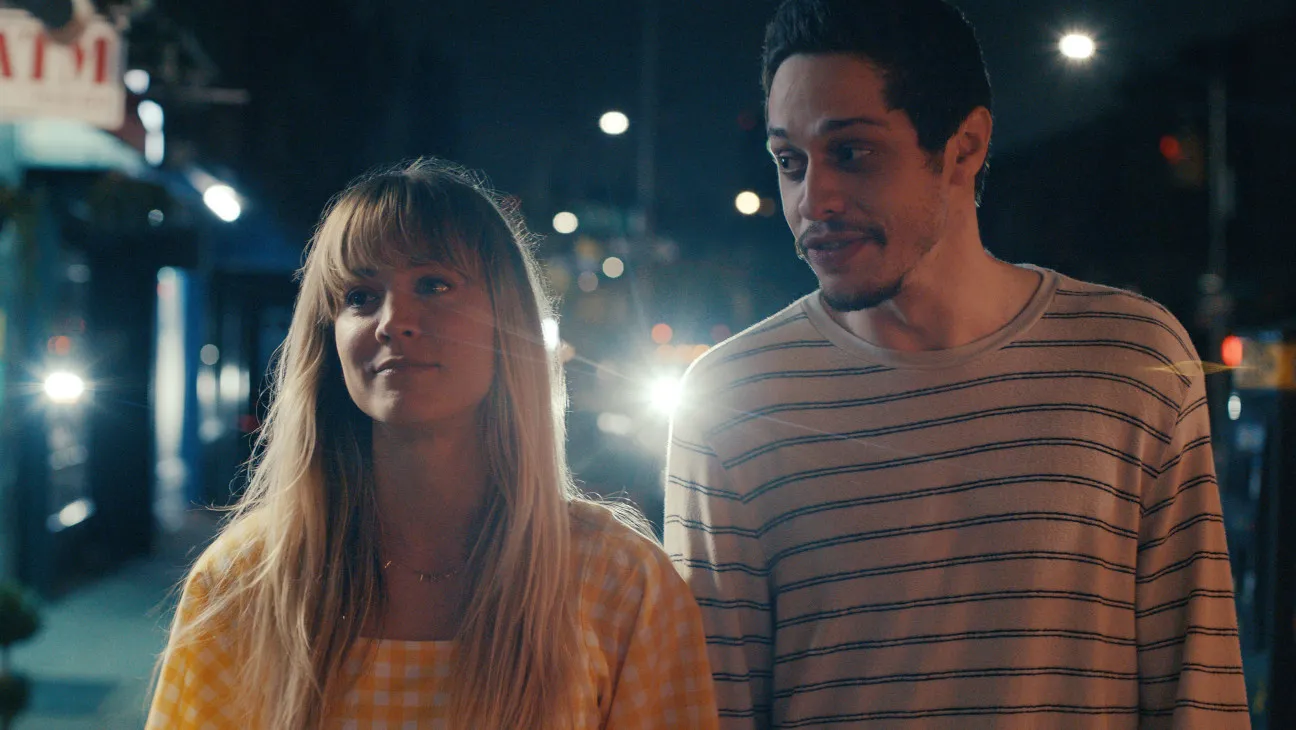Analyze the image in a comprehensive and detailed manner. In the image, there are two individuals captured in a night-time urban setting, illuminated by street lights and various signs, creating a lively atmosphere. The woman, wearing a bright yellow and white gingham dress, directs her attention slightly upward, displaying a contemplative expression. The man accompanying her, dressed in a casual striped shirt, smiles gently as he looks at her, indicating a moment of shared interaction or conversation. The setting includes elements such as a glowing ATM sign and blurred background lights, which suggest a busy city environment. The overall mood is one of a quiet, personal moment shared between two people amid the bustle of city life. 